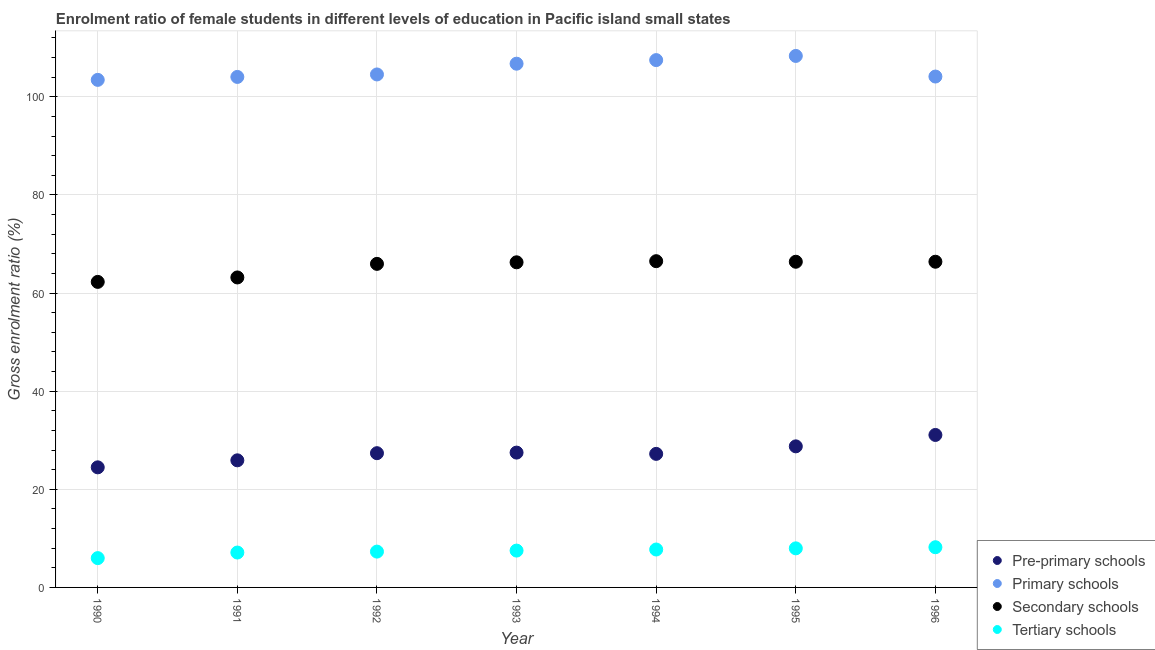Is the number of dotlines equal to the number of legend labels?
Ensure brevity in your answer.  Yes. What is the gross enrolment ratio(male) in tertiary schools in 1994?
Keep it short and to the point. 7.73. Across all years, what is the maximum gross enrolment ratio(male) in primary schools?
Offer a very short reply. 108.34. Across all years, what is the minimum gross enrolment ratio(male) in secondary schools?
Your answer should be compact. 62.28. In which year was the gross enrolment ratio(male) in secondary schools maximum?
Provide a short and direct response. 1994. What is the total gross enrolment ratio(male) in secondary schools in the graph?
Ensure brevity in your answer.  456.99. What is the difference between the gross enrolment ratio(male) in primary schools in 1994 and that in 1996?
Offer a very short reply. 3.35. What is the difference between the gross enrolment ratio(male) in secondary schools in 1994 and the gross enrolment ratio(male) in primary schools in 1995?
Ensure brevity in your answer.  -41.84. What is the average gross enrolment ratio(male) in secondary schools per year?
Your answer should be compact. 65.28. In the year 1995, what is the difference between the gross enrolment ratio(male) in tertiary schools and gross enrolment ratio(male) in pre-primary schools?
Your answer should be very brief. -20.79. In how many years, is the gross enrolment ratio(male) in primary schools greater than 84 %?
Provide a succinct answer. 7. What is the ratio of the gross enrolment ratio(male) in pre-primary schools in 1991 to that in 1995?
Your answer should be compact. 0.9. Is the gross enrolment ratio(male) in pre-primary schools in 1991 less than that in 1993?
Make the answer very short. Yes. What is the difference between the highest and the second highest gross enrolment ratio(male) in primary schools?
Provide a short and direct response. 0.85. What is the difference between the highest and the lowest gross enrolment ratio(male) in secondary schools?
Keep it short and to the point. 4.22. Is the sum of the gross enrolment ratio(male) in primary schools in 1991 and 1994 greater than the maximum gross enrolment ratio(male) in secondary schools across all years?
Give a very brief answer. Yes. Is it the case that in every year, the sum of the gross enrolment ratio(male) in pre-primary schools and gross enrolment ratio(male) in tertiary schools is greater than the sum of gross enrolment ratio(male) in primary schools and gross enrolment ratio(male) in secondary schools?
Keep it short and to the point. No. Is the gross enrolment ratio(male) in pre-primary schools strictly greater than the gross enrolment ratio(male) in secondary schools over the years?
Ensure brevity in your answer.  No. Is the gross enrolment ratio(male) in pre-primary schools strictly less than the gross enrolment ratio(male) in primary schools over the years?
Offer a terse response. Yes. What is the difference between two consecutive major ticks on the Y-axis?
Give a very brief answer. 20. Are the values on the major ticks of Y-axis written in scientific E-notation?
Your response must be concise. No. Does the graph contain any zero values?
Provide a short and direct response. No. Does the graph contain grids?
Your response must be concise. Yes. Where does the legend appear in the graph?
Ensure brevity in your answer.  Bottom right. What is the title of the graph?
Provide a short and direct response. Enrolment ratio of female students in different levels of education in Pacific island small states. Does "International Monetary Fund" appear as one of the legend labels in the graph?
Make the answer very short. No. What is the label or title of the X-axis?
Provide a succinct answer. Year. What is the Gross enrolment ratio (%) of Pre-primary schools in 1990?
Offer a very short reply. 24.48. What is the Gross enrolment ratio (%) in Primary schools in 1990?
Offer a very short reply. 103.46. What is the Gross enrolment ratio (%) of Secondary schools in 1990?
Keep it short and to the point. 62.28. What is the Gross enrolment ratio (%) in Tertiary schools in 1990?
Make the answer very short. 5.97. What is the Gross enrolment ratio (%) in Pre-primary schools in 1991?
Keep it short and to the point. 25.91. What is the Gross enrolment ratio (%) in Primary schools in 1991?
Give a very brief answer. 104.06. What is the Gross enrolment ratio (%) of Secondary schools in 1991?
Offer a terse response. 63.19. What is the Gross enrolment ratio (%) in Tertiary schools in 1991?
Give a very brief answer. 7.11. What is the Gross enrolment ratio (%) of Pre-primary schools in 1992?
Your response must be concise. 27.36. What is the Gross enrolment ratio (%) in Primary schools in 1992?
Provide a succinct answer. 104.57. What is the Gross enrolment ratio (%) of Secondary schools in 1992?
Provide a succinct answer. 65.96. What is the Gross enrolment ratio (%) in Tertiary schools in 1992?
Provide a short and direct response. 7.3. What is the Gross enrolment ratio (%) in Pre-primary schools in 1993?
Provide a short and direct response. 27.48. What is the Gross enrolment ratio (%) in Primary schools in 1993?
Keep it short and to the point. 106.76. What is the Gross enrolment ratio (%) of Secondary schools in 1993?
Ensure brevity in your answer.  66.28. What is the Gross enrolment ratio (%) in Tertiary schools in 1993?
Your answer should be compact. 7.51. What is the Gross enrolment ratio (%) in Pre-primary schools in 1994?
Ensure brevity in your answer.  27.22. What is the Gross enrolment ratio (%) in Primary schools in 1994?
Your answer should be very brief. 107.49. What is the Gross enrolment ratio (%) of Secondary schools in 1994?
Ensure brevity in your answer.  66.51. What is the Gross enrolment ratio (%) of Tertiary schools in 1994?
Provide a succinct answer. 7.73. What is the Gross enrolment ratio (%) in Pre-primary schools in 1995?
Your answer should be very brief. 28.76. What is the Gross enrolment ratio (%) of Primary schools in 1995?
Make the answer very short. 108.34. What is the Gross enrolment ratio (%) of Secondary schools in 1995?
Your answer should be compact. 66.39. What is the Gross enrolment ratio (%) of Tertiary schools in 1995?
Your answer should be very brief. 7.97. What is the Gross enrolment ratio (%) in Pre-primary schools in 1996?
Offer a very short reply. 31.08. What is the Gross enrolment ratio (%) in Primary schools in 1996?
Your answer should be compact. 104.14. What is the Gross enrolment ratio (%) in Secondary schools in 1996?
Your response must be concise. 66.39. What is the Gross enrolment ratio (%) of Tertiary schools in 1996?
Offer a very short reply. 8.19. Across all years, what is the maximum Gross enrolment ratio (%) of Pre-primary schools?
Offer a very short reply. 31.08. Across all years, what is the maximum Gross enrolment ratio (%) of Primary schools?
Ensure brevity in your answer.  108.34. Across all years, what is the maximum Gross enrolment ratio (%) of Secondary schools?
Your answer should be very brief. 66.51. Across all years, what is the maximum Gross enrolment ratio (%) in Tertiary schools?
Keep it short and to the point. 8.19. Across all years, what is the minimum Gross enrolment ratio (%) in Pre-primary schools?
Offer a terse response. 24.48. Across all years, what is the minimum Gross enrolment ratio (%) of Primary schools?
Offer a terse response. 103.46. Across all years, what is the minimum Gross enrolment ratio (%) in Secondary schools?
Your answer should be very brief. 62.28. Across all years, what is the minimum Gross enrolment ratio (%) of Tertiary schools?
Your answer should be very brief. 5.97. What is the total Gross enrolment ratio (%) of Pre-primary schools in the graph?
Ensure brevity in your answer.  192.3. What is the total Gross enrolment ratio (%) in Primary schools in the graph?
Your answer should be compact. 738.84. What is the total Gross enrolment ratio (%) in Secondary schools in the graph?
Your answer should be very brief. 456.99. What is the total Gross enrolment ratio (%) in Tertiary schools in the graph?
Your response must be concise. 51.78. What is the difference between the Gross enrolment ratio (%) in Pre-primary schools in 1990 and that in 1991?
Provide a short and direct response. -1.43. What is the difference between the Gross enrolment ratio (%) of Primary schools in 1990 and that in 1991?
Provide a succinct answer. -0.6. What is the difference between the Gross enrolment ratio (%) of Secondary schools in 1990 and that in 1991?
Ensure brevity in your answer.  -0.9. What is the difference between the Gross enrolment ratio (%) in Tertiary schools in 1990 and that in 1991?
Offer a very short reply. -1.14. What is the difference between the Gross enrolment ratio (%) of Pre-primary schools in 1990 and that in 1992?
Your response must be concise. -2.88. What is the difference between the Gross enrolment ratio (%) of Primary schools in 1990 and that in 1992?
Provide a succinct answer. -1.1. What is the difference between the Gross enrolment ratio (%) of Secondary schools in 1990 and that in 1992?
Your answer should be compact. -3.67. What is the difference between the Gross enrolment ratio (%) of Tertiary schools in 1990 and that in 1992?
Provide a short and direct response. -1.33. What is the difference between the Gross enrolment ratio (%) of Pre-primary schools in 1990 and that in 1993?
Your response must be concise. -3. What is the difference between the Gross enrolment ratio (%) of Primary schools in 1990 and that in 1993?
Make the answer very short. -3.3. What is the difference between the Gross enrolment ratio (%) of Secondary schools in 1990 and that in 1993?
Provide a short and direct response. -3.99. What is the difference between the Gross enrolment ratio (%) in Tertiary schools in 1990 and that in 1993?
Provide a succinct answer. -1.53. What is the difference between the Gross enrolment ratio (%) in Pre-primary schools in 1990 and that in 1994?
Your answer should be very brief. -2.74. What is the difference between the Gross enrolment ratio (%) in Primary schools in 1990 and that in 1994?
Make the answer very short. -4.03. What is the difference between the Gross enrolment ratio (%) in Secondary schools in 1990 and that in 1994?
Keep it short and to the point. -4.22. What is the difference between the Gross enrolment ratio (%) of Tertiary schools in 1990 and that in 1994?
Offer a very short reply. -1.75. What is the difference between the Gross enrolment ratio (%) in Pre-primary schools in 1990 and that in 1995?
Provide a short and direct response. -4.28. What is the difference between the Gross enrolment ratio (%) of Primary schools in 1990 and that in 1995?
Give a very brief answer. -4.88. What is the difference between the Gross enrolment ratio (%) of Secondary schools in 1990 and that in 1995?
Make the answer very short. -4.11. What is the difference between the Gross enrolment ratio (%) of Tertiary schools in 1990 and that in 1995?
Your answer should be very brief. -1.99. What is the difference between the Gross enrolment ratio (%) of Pre-primary schools in 1990 and that in 1996?
Give a very brief answer. -6.6. What is the difference between the Gross enrolment ratio (%) in Primary schools in 1990 and that in 1996?
Your answer should be very brief. -0.68. What is the difference between the Gross enrolment ratio (%) in Secondary schools in 1990 and that in 1996?
Offer a terse response. -4.11. What is the difference between the Gross enrolment ratio (%) of Tertiary schools in 1990 and that in 1996?
Your answer should be compact. -2.22. What is the difference between the Gross enrolment ratio (%) of Pre-primary schools in 1991 and that in 1992?
Offer a very short reply. -1.45. What is the difference between the Gross enrolment ratio (%) in Primary schools in 1991 and that in 1992?
Ensure brevity in your answer.  -0.5. What is the difference between the Gross enrolment ratio (%) in Secondary schools in 1991 and that in 1992?
Ensure brevity in your answer.  -2.77. What is the difference between the Gross enrolment ratio (%) of Tertiary schools in 1991 and that in 1992?
Your response must be concise. -0.19. What is the difference between the Gross enrolment ratio (%) of Pre-primary schools in 1991 and that in 1993?
Provide a succinct answer. -1.57. What is the difference between the Gross enrolment ratio (%) in Primary schools in 1991 and that in 1993?
Give a very brief answer. -2.7. What is the difference between the Gross enrolment ratio (%) of Secondary schools in 1991 and that in 1993?
Offer a terse response. -3.09. What is the difference between the Gross enrolment ratio (%) in Tertiary schools in 1991 and that in 1993?
Your response must be concise. -0.4. What is the difference between the Gross enrolment ratio (%) in Pre-primary schools in 1991 and that in 1994?
Offer a terse response. -1.31. What is the difference between the Gross enrolment ratio (%) in Primary schools in 1991 and that in 1994?
Your answer should be compact. -3.43. What is the difference between the Gross enrolment ratio (%) of Secondary schools in 1991 and that in 1994?
Give a very brief answer. -3.32. What is the difference between the Gross enrolment ratio (%) of Tertiary schools in 1991 and that in 1994?
Offer a terse response. -0.62. What is the difference between the Gross enrolment ratio (%) in Pre-primary schools in 1991 and that in 1995?
Provide a succinct answer. -2.85. What is the difference between the Gross enrolment ratio (%) of Primary schools in 1991 and that in 1995?
Keep it short and to the point. -4.28. What is the difference between the Gross enrolment ratio (%) in Secondary schools in 1991 and that in 1995?
Provide a short and direct response. -3.2. What is the difference between the Gross enrolment ratio (%) of Tertiary schools in 1991 and that in 1995?
Ensure brevity in your answer.  -0.85. What is the difference between the Gross enrolment ratio (%) of Pre-primary schools in 1991 and that in 1996?
Keep it short and to the point. -5.17. What is the difference between the Gross enrolment ratio (%) of Primary schools in 1991 and that in 1996?
Your response must be concise. -0.08. What is the difference between the Gross enrolment ratio (%) in Secondary schools in 1991 and that in 1996?
Give a very brief answer. -3.2. What is the difference between the Gross enrolment ratio (%) of Tertiary schools in 1991 and that in 1996?
Make the answer very short. -1.08. What is the difference between the Gross enrolment ratio (%) in Pre-primary schools in 1992 and that in 1993?
Provide a short and direct response. -0.12. What is the difference between the Gross enrolment ratio (%) of Primary schools in 1992 and that in 1993?
Provide a short and direct response. -2.19. What is the difference between the Gross enrolment ratio (%) of Secondary schools in 1992 and that in 1993?
Your answer should be very brief. -0.32. What is the difference between the Gross enrolment ratio (%) in Tertiary schools in 1992 and that in 1993?
Give a very brief answer. -0.21. What is the difference between the Gross enrolment ratio (%) of Pre-primary schools in 1992 and that in 1994?
Your answer should be very brief. 0.14. What is the difference between the Gross enrolment ratio (%) of Primary schools in 1992 and that in 1994?
Ensure brevity in your answer.  -2.93. What is the difference between the Gross enrolment ratio (%) of Secondary schools in 1992 and that in 1994?
Offer a terse response. -0.55. What is the difference between the Gross enrolment ratio (%) in Tertiary schools in 1992 and that in 1994?
Offer a very short reply. -0.43. What is the difference between the Gross enrolment ratio (%) of Pre-primary schools in 1992 and that in 1995?
Offer a terse response. -1.39. What is the difference between the Gross enrolment ratio (%) of Primary schools in 1992 and that in 1995?
Provide a short and direct response. -3.77. What is the difference between the Gross enrolment ratio (%) in Secondary schools in 1992 and that in 1995?
Provide a short and direct response. -0.43. What is the difference between the Gross enrolment ratio (%) of Tertiary schools in 1992 and that in 1995?
Make the answer very short. -0.66. What is the difference between the Gross enrolment ratio (%) of Pre-primary schools in 1992 and that in 1996?
Offer a very short reply. -3.72. What is the difference between the Gross enrolment ratio (%) in Primary schools in 1992 and that in 1996?
Your answer should be compact. 0.43. What is the difference between the Gross enrolment ratio (%) in Secondary schools in 1992 and that in 1996?
Your response must be concise. -0.44. What is the difference between the Gross enrolment ratio (%) in Tertiary schools in 1992 and that in 1996?
Your answer should be compact. -0.89. What is the difference between the Gross enrolment ratio (%) of Pre-primary schools in 1993 and that in 1994?
Ensure brevity in your answer.  0.26. What is the difference between the Gross enrolment ratio (%) in Primary schools in 1993 and that in 1994?
Give a very brief answer. -0.73. What is the difference between the Gross enrolment ratio (%) of Secondary schools in 1993 and that in 1994?
Your response must be concise. -0.23. What is the difference between the Gross enrolment ratio (%) in Tertiary schools in 1993 and that in 1994?
Make the answer very short. -0.22. What is the difference between the Gross enrolment ratio (%) in Pre-primary schools in 1993 and that in 1995?
Your answer should be compact. -1.27. What is the difference between the Gross enrolment ratio (%) of Primary schools in 1993 and that in 1995?
Your answer should be very brief. -1.58. What is the difference between the Gross enrolment ratio (%) in Secondary schools in 1993 and that in 1995?
Your response must be concise. -0.11. What is the difference between the Gross enrolment ratio (%) of Tertiary schools in 1993 and that in 1995?
Offer a very short reply. -0.46. What is the difference between the Gross enrolment ratio (%) in Pre-primary schools in 1993 and that in 1996?
Your answer should be compact. -3.6. What is the difference between the Gross enrolment ratio (%) in Primary schools in 1993 and that in 1996?
Offer a very short reply. 2.62. What is the difference between the Gross enrolment ratio (%) in Secondary schools in 1993 and that in 1996?
Your response must be concise. -0.12. What is the difference between the Gross enrolment ratio (%) of Tertiary schools in 1993 and that in 1996?
Provide a succinct answer. -0.69. What is the difference between the Gross enrolment ratio (%) in Pre-primary schools in 1994 and that in 1995?
Your answer should be compact. -1.53. What is the difference between the Gross enrolment ratio (%) of Primary schools in 1994 and that in 1995?
Give a very brief answer. -0.85. What is the difference between the Gross enrolment ratio (%) in Secondary schools in 1994 and that in 1995?
Provide a short and direct response. 0.12. What is the difference between the Gross enrolment ratio (%) of Tertiary schools in 1994 and that in 1995?
Give a very brief answer. -0.24. What is the difference between the Gross enrolment ratio (%) in Pre-primary schools in 1994 and that in 1996?
Ensure brevity in your answer.  -3.86. What is the difference between the Gross enrolment ratio (%) of Primary schools in 1994 and that in 1996?
Provide a succinct answer. 3.35. What is the difference between the Gross enrolment ratio (%) of Secondary schools in 1994 and that in 1996?
Ensure brevity in your answer.  0.11. What is the difference between the Gross enrolment ratio (%) of Tertiary schools in 1994 and that in 1996?
Keep it short and to the point. -0.46. What is the difference between the Gross enrolment ratio (%) in Pre-primary schools in 1995 and that in 1996?
Offer a very short reply. -2.32. What is the difference between the Gross enrolment ratio (%) in Primary schools in 1995 and that in 1996?
Keep it short and to the point. 4.2. What is the difference between the Gross enrolment ratio (%) of Secondary schools in 1995 and that in 1996?
Provide a short and direct response. -0. What is the difference between the Gross enrolment ratio (%) of Tertiary schools in 1995 and that in 1996?
Offer a very short reply. -0.23. What is the difference between the Gross enrolment ratio (%) in Pre-primary schools in 1990 and the Gross enrolment ratio (%) in Primary schools in 1991?
Offer a very short reply. -79.58. What is the difference between the Gross enrolment ratio (%) of Pre-primary schools in 1990 and the Gross enrolment ratio (%) of Secondary schools in 1991?
Offer a very short reply. -38.71. What is the difference between the Gross enrolment ratio (%) in Pre-primary schools in 1990 and the Gross enrolment ratio (%) in Tertiary schools in 1991?
Provide a short and direct response. 17.37. What is the difference between the Gross enrolment ratio (%) in Primary schools in 1990 and the Gross enrolment ratio (%) in Secondary schools in 1991?
Give a very brief answer. 40.28. What is the difference between the Gross enrolment ratio (%) in Primary schools in 1990 and the Gross enrolment ratio (%) in Tertiary schools in 1991?
Keep it short and to the point. 96.35. What is the difference between the Gross enrolment ratio (%) of Secondary schools in 1990 and the Gross enrolment ratio (%) of Tertiary schools in 1991?
Your response must be concise. 55.17. What is the difference between the Gross enrolment ratio (%) in Pre-primary schools in 1990 and the Gross enrolment ratio (%) in Primary schools in 1992?
Keep it short and to the point. -80.09. What is the difference between the Gross enrolment ratio (%) of Pre-primary schools in 1990 and the Gross enrolment ratio (%) of Secondary schools in 1992?
Your response must be concise. -41.48. What is the difference between the Gross enrolment ratio (%) of Pre-primary schools in 1990 and the Gross enrolment ratio (%) of Tertiary schools in 1992?
Your response must be concise. 17.18. What is the difference between the Gross enrolment ratio (%) of Primary schools in 1990 and the Gross enrolment ratio (%) of Secondary schools in 1992?
Your response must be concise. 37.51. What is the difference between the Gross enrolment ratio (%) in Primary schools in 1990 and the Gross enrolment ratio (%) in Tertiary schools in 1992?
Offer a very short reply. 96.16. What is the difference between the Gross enrolment ratio (%) of Secondary schools in 1990 and the Gross enrolment ratio (%) of Tertiary schools in 1992?
Your response must be concise. 54.98. What is the difference between the Gross enrolment ratio (%) in Pre-primary schools in 1990 and the Gross enrolment ratio (%) in Primary schools in 1993?
Provide a short and direct response. -82.28. What is the difference between the Gross enrolment ratio (%) in Pre-primary schools in 1990 and the Gross enrolment ratio (%) in Secondary schools in 1993?
Keep it short and to the point. -41.8. What is the difference between the Gross enrolment ratio (%) of Pre-primary schools in 1990 and the Gross enrolment ratio (%) of Tertiary schools in 1993?
Provide a short and direct response. 16.97. What is the difference between the Gross enrolment ratio (%) in Primary schools in 1990 and the Gross enrolment ratio (%) in Secondary schools in 1993?
Your response must be concise. 37.19. What is the difference between the Gross enrolment ratio (%) of Primary schools in 1990 and the Gross enrolment ratio (%) of Tertiary schools in 1993?
Make the answer very short. 95.96. What is the difference between the Gross enrolment ratio (%) of Secondary schools in 1990 and the Gross enrolment ratio (%) of Tertiary schools in 1993?
Provide a succinct answer. 54.77. What is the difference between the Gross enrolment ratio (%) of Pre-primary schools in 1990 and the Gross enrolment ratio (%) of Primary schools in 1994?
Provide a short and direct response. -83.01. What is the difference between the Gross enrolment ratio (%) of Pre-primary schools in 1990 and the Gross enrolment ratio (%) of Secondary schools in 1994?
Provide a succinct answer. -42.02. What is the difference between the Gross enrolment ratio (%) of Pre-primary schools in 1990 and the Gross enrolment ratio (%) of Tertiary schools in 1994?
Your answer should be very brief. 16.75. What is the difference between the Gross enrolment ratio (%) of Primary schools in 1990 and the Gross enrolment ratio (%) of Secondary schools in 1994?
Offer a very short reply. 36.96. What is the difference between the Gross enrolment ratio (%) in Primary schools in 1990 and the Gross enrolment ratio (%) in Tertiary schools in 1994?
Offer a terse response. 95.74. What is the difference between the Gross enrolment ratio (%) in Secondary schools in 1990 and the Gross enrolment ratio (%) in Tertiary schools in 1994?
Your answer should be compact. 54.55. What is the difference between the Gross enrolment ratio (%) of Pre-primary schools in 1990 and the Gross enrolment ratio (%) of Primary schools in 1995?
Make the answer very short. -83.86. What is the difference between the Gross enrolment ratio (%) of Pre-primary schools in 1990 and the Gross enrolment ratio (%) of Secondary schools in 1995?
Keep it short and to the point. -41.91. What is the difference between the Gross enrolment ratio (%) of Pre-primary schools in 1990 and the Gross enrolment ratio (%) of Tertiary schools in 1995?
Ensure brevity in your answer.  16.52. What is the difference between the Gross enrolment ratio (%) in Primary schools in 1990 and the Gross enrolment ratio (%) in Secondary schools in 1995?
Your response must be concise. 37.08. What is the difference between the Gross enrolment ratio (%) of Primary schools in 1990 and the Gross enrolment ratio (%) of Tertiary schools in 1995?
Make the answer very short. 95.5. What is the difference between the Gross enrolment ratio (%) in Secondary schools in 1990 and the Gross enrolment ratio (%) in Tertiary schools in 1995?
Give a very brief answer. 54.32. What is the difference between the Gross enrolment ratio (%) of Pre-primary schools in 1990 and the Gross enrolment ratio (%) of Primary schools in 1996?
Offer a terse response. -79.66. What is the difference between the Gross enrolment ratio (%) in Pre-primary schools in 1990 and the Gross enrolment ratio (%) in Secondary schools in 1996?
Keep it short and to the point. -41.91. What is the difference between the Gross enrolment ratio (%) of Pre-primary schools in 1990 and the Gross enrolment ratio (%) of Tertiary schools in 1996?
Provide a short and direct response. 16.29. What is the difference between the Gross enrolment ratio (%) in Primary schools in 1990 and the Gross enrolment ratio (%) in Secondary schools in 1996?
Give a very brief answer. 37.07. What is the difference between the Gross enrolment ratio (%) of Primary schools in 1990 and the Gross enrolment ratio (%) of Tertiary schools in 1996?
Provide a short and direct response. 95.27. What is the difference between the Gross enrolment ratio (%) in Secondary schools in 1990 and the Gross enrolment ratio (%) in Tertiary schools in 1996?
Your answer should be very brief. 54.09. What is the difference between the Gross enrolment ratio (%) in Pre-primary schools in 1991 and the Gross enrolment ratio (%) in Primary schools in 1992?
Keep it short and to the point. -78.66. What is the difference between the Gross enrolment ratio (%) of Pre-primary schools in 1991 and the Gross enrolment ratio (%) of Secondary schools in 1992?
Your response must be concise. -40.05. What is the difference between the Gross enrolment ratio (%) of Pre-primary schools in 1991 and the Gross enrolment ratio (%) of Tertiary schools in 1992?
Make the answer very short. 18.61. What is the difference between the Gross enrolment ratio (%) of Primary schools in 1991 and the Gross enrolment ratio (%) of Secondary schools in 1992?
Keep it short and to the point. 38.11. What is the difference between the Gross enrolment ratio (%) in Primary schools in 1991 and the Gross enrolment ratio (%) in Tertiary schools in 1992?
Provide a short and direct response. 96.76. What is the difference between the Gross enrolment ratio (%) in Secondary schools in 1991 and the Gross enrolment ratio (%) in Tertiary schools in 1992?
Offer a terse response. 55.89. What is the difference between the Gross enrolment ratio (%) in Pre-primary schools in 1991 and the Gross enrolment ratio (%) in Primary schools in 1993?
Offer a very short reply. -80.85. What is the difference between the Gross enrolment ratio (%) in Pre-primary schools in 1991 and the Gross enrolment ratio (%) in Secondary schools in 1993?
Provide a short and direct response. -40.37. What is the difference between the Gross enrolment ratio (%) of Pre-primary schools in 1991 and the Gross enrolment ratio (%) of Tertiary schools in 1993?
Your response must be concise. 18.4. What is the difference between the Gross enrolment ratio (%) of Primary schools in 1991 and the Gross enrolment ratio (%) of Secondary schools in 1993?
Your answer should be very brief. 37.79. What is the difference between the Gross enrolment ratio (%) of Primary schools in 1991 and the Gross enrolment ratio (%) of Tertiary schools in 1993?
Your answer should be very brief. 96.56. What is the difference between the Gross enrolment ratio (%) of Secondary schools in 1991 and the Gross enrolment ratio (%) of Tertiary schools in 1993?
Your response must be concise. 55.68. What is the difference between the Gross enrolment ratio (%) in Pre-primary schools in 1991 and the Gross enrolment ratio (%) in Primary schools in 1994?
Ensure brevity in your answer.  -81.58. What is the difference between the Gross enrolment ratio (%) of Pre-primary schools in 1991 and the Gross enrolment ratio (%) of Secondary schools in 1994?
Your answer should be very brief. -40.59. What is the difference between the Gross enrolment ratio (%) of Pre-primary schools in 1991 and the Gross enrolment ratio (%) of Tertiary schools in 1994?
Offer a very short reply. 18.18. What is the difference between the Gross enrolment ratio (%) of Primary schools in 1991 and the Gross enrolment ratio (%) of Secondary schools in 1994?
Your answer should be very brief. 37.56. What is the difference between the Gross enrolment ratio (%) in Primary schools in 1991 and the Gross enrolment ratio (%) in Tertiary schools in 1994?
Make the answer very short. 96.34. What is the difference between the Gross enrolment ratio (%) in Secondary schools in 1991 and the Gross enrolment ratio (%) in Tertiary schools in 1994?
Your answer should be compact. 55.46. What is the difference between the Gross enrolment ratio (%) in Pre-primary schools in 1991 and the Gross enrolment ratio (%) in Primary schools in 1995?
Provide a short and direct response. -82.43. What is the difference between the Gross enrolment ratio (%) in Pre-primary schools in 1991 and the Gross enrolment ratio (%) in Secondary schools in 1995?
Keep it short and to the point. -40.48. What is the difference between the Gross enrolment ratio (%) in Pre-primary schools in 1991 and the Gross enrolment ratio (%) in Tertiary schools in 1995?
Offer a very short reply. 17.95. What is the difference between the Gross enrolment ratio (%) in Primary schools in 1991 and the Gross enrolment ratio (%) in Secondary schools in 1995?
Give a very brief answer. 37.68. What is the difference between the Gross enrolment ratio (%) in Primary schools in 1991 and the Gross enrolment ratio (%) in Tertiary schools in 1995?
Keep it short and to the point. 96.1. What is the difference between the Gross enrolment ratio (%) in Secondary schools in 1991 and the Gross enrolment ratio (%) in Tertiary schools in 1995?
Make the answer very short. 55.22. What is the difference between the Gross enrolment ratio (%) of Pre-primary schools in 1991 and the Gross enrolment ratio (%) of Primary schools in 1996?
Ensure brevity in your answer.  -78.23. What is the difference between the Gross enrolment ratio (%) of Pre-primary schools in 1991 and the Gross enrolment ratio (%) of Secondary schools in 1996?
Keep it short and to the point. -40.48. What is the difference between the Gross enrolment ratio (%) in Pre-primary schools in 1991 and the Gross enrolment ratio (%) in Tertiary schools in 1996?
Your response must be concise. 17.72. What is the difference between the Gross enrolment ratio (%) in Primary schools in 1991 and the Gross enrolment ratio (%) in Secondary schools in 1996?
Offer a very short reply. 37.67. What is the difference between the Gross enrolment ratio (%) in Primary schools in 1991 and the Gross enrolment ratio (%) in Tertiary schools in 1996?
Make the answer very short. 95.87. What is the difference between the Gross enrolment ratio (%) in Secondary schools in 1991 and the Gross enrolment ratio (%) in Tertiary schools in 1996?
Give a very brief answer. 54.99. What is the difference between the Gross enrolment ratio (%) in Pre-primary schools in 1992 and the Gross enrolment ratio (%) in Primary schools in 1993?
Make the answer very short. -79.4. What is the difference between the Gross enrolment ratio (%) of Pre-primary schools in 1992 and the Gross enrolment ratio (%) of Secondary schools in 1993?
Offer a very short reply. -38.91. What is the difference between the Gross enrolment ratio (%) in Pre-primary schools in 1992 and the Gross enrolment ratio (%) in Tertiary schools in 1993?
Make the answer very short. 19.86. What is the difference between the Gross enrolment ratio (%) of Primary schools in 1992 and the Gross enrolment ratio (%) of Secondary schools in 1993?
Offer a very short reply. 38.29. What is the difference between the Gross enrolment ratio (%) of Primary schools in 1992 and the Gross enrolment ratio (%) of Tertiary schools in 1993?
Your response must be concise. 97.06. What is the difference between the Gross enrolment ratio (%) of Secondary schools in 1992 and the Gross enrolment ratio (%) of Tertiary schools in 1993?
Make the answer very short. 58.45. What is the difference between the Gross enrolment ratio (%) of Pre-primary schools in 1992 and the Gross enrolment ratio (%) of Primary schools in 1994?
Your answer should be very brief. -80.13. What is the difference between the Gross enrolment ratio (%) in Pre-primary schools in 1992 and the Gross enrolment ratio (%) in Secondary schools in 1994?
Give a very brief answer. -39.14. What is the difference between the Gross enrolment ratio (%) of Pre-primary schools in 1992 and the Gross enrolment ratio (%) of Tertiary schools in 1994?
Provide a succinct answer. 19.64. What is the difference between the Gross enrolment ratio (%) of Primary schools in 1992 and the Gross enrolment ratio (%) of Secondary schools in 1994?
Give a very brief answer. 38.06. What is the difference between the Gross enrolment ratio (%) of Primary schools in 1992 and the Gross enrolment ratio (%) of Tertiary schools in 1994?
Offer a very short reply. 96.84. What is the difference between the Gross enrolment ratio (%) of Secondary schools in 1992 and the Gross enrolment ratio (%) of Tertiary schools in 1994?
Your answer should be compact. 58.23. What is the difference between the Gross enrolment ratio (%) of Pre-primary schools in 1992 and the Gross enrolment ratio (%) of Primary schools in 1995?
Give a very brief answer. -80.98. What is the difference between the Gross enrolment ratio (%) of Pre-primary schools in 1992 and the Gross enrolment ratio (%) of Secondary schools in 1995?
Give a very brief answer. -39.02. What is the difference between the Gross enrolment ratio (%) of Pre-primary schools in 1992 and the Gross enrolment ratio (%) of Tertiary schools in 1995?
Keep it short and to the point. 19.4. What is the difference between the Gross enrolment ratio (%) of Primary schools in 1992 and the Gross enrolment ratio (%) of Secondary schools in 1995?
Keep it short and to the point. 38.18. What is the difference between the Gross enrolment ratio (%) of Primary schools in 1992 and the Gross enrolment ratio (%) of Tertiary schools in 1995?
Make the answer very short. 96.6. What is the difference between the Gross enrolment ratio (%) in Secondary schools in 1992 and the Gross enrolment ratio (%) in Tertiary schools in 1995?
Provide a succinct answer. 57.99. What is the difference between the Gross enrolment ratio (%) of Pre-primary schools in 1992 and the Gross enrolment ratio (%) of Primary schools in 1996?
Give a very brief answer. -76.78. What is the difference between the Gross enrolment ratio (%) in Pre-primary schools in 1992 and the Gross enrolment ratio (%) in Secondary schools in 1996?
Offer a very short reply. -39.03. What is the difference between the Gross enrolment ratio (%) in Pre-primary schools in 1992 and the Gross enrolment ratio (%) in Tertiary schools in 1996?
Your response must be concise. 19.17. What is the difference between the Gross enrolment ratio (%) in Primary schools in 1992 and the Gross enrolment ratio (%) in Secondary schools in 1996?
Provide a succinct answer. 38.18. What is the difference between the Gross enrolment ratio (%) of Primary schools in 1992 and the Gross enrolment ratio (%) of Tertiary schools in 1996?
Your response must be concise. 96.38. What is the difference between the Gross enrolment ratio (%) in Secondary schools in 1992 and the Gross enrolment ratio (%) in Tertiary schools in 1996?
Give a very brief answer. 57.76. What is the difference between the Gross enrolment ratio (%) in Pre-primary schools in 1993 and the Gross enrolment ratio (%) in Primary schools in 1994?
Offer a very short reply. -80.01. What is the difference between the Gross enrolment ratio (%) in Pre-primary schools in 1993 and the Gross enrolment ratio (%) in Secondary schools in 1994?
Offer a terse response. -39.02. What is the difference between the Gross enrolment ratio (%) in Pre-primary schools in 1993 and the Gross enrolment ratio (%) in Tertiary schools in 1994?
Provide a succinct answer. 19.76. What is the difference between the Gross enrolment ratio (%) in Primary schools in 1993 and the Gross enrolment ratio (%) in Secondary schools in 1994?
Offer a terse response. 40.26. What is the difference between the Gross enrolment ratio (%) of Primary schools in 1993 and the Gross enrolment ratio (%) of Tertiary schools in 1994?
Provide a succinct answer. 99.03. What is the difference between the Gross enrolment ratio (%) in Secondary schools in 1993 and the Gross enrolment ratio (%) in Tertiary schools in 1994?
Your answer should be very brief. 58.55. What is the difference between the Gross enrolment ratio (%) of Pre-primary schools in 1993 and the Gross enrolment ratio (%) of Primary schools in 1995?
Give a very brief answer. -80.86. What is the difference between the Gross enrolment ratio (%) of Pre-primary schools in 1993 and the Gross enrolment ratio (%) of Secondary schools in 1995?
Your response must be concise. -38.9. What is the difference between the Gross enrolment ratio (%) of Pre-primary schools in 1993 and the Gross enrolment ratio (%) of Tertiary schools in 1995?
Provide a short and direct response. 19.52. What is the difference between the Gross enrolment ratio (%) in Primary schools in 1993 and the Gross enrolment ratio (%) in Secondary schools in 1995?
Provide a short and direct response. 40.37. What is the difference between the Gross enrolment ratio (%) of Primary schools in 1993 and the Gross enrolment ratio (%) of Tertiary schools in 1995?
Ensure brevity in your answer.  98.8. What is the difference between the Gross enrolment ratio (%) of Secondary schools in 1993 and the Gross enrolment ratio (%) of Tertiary schools in 1995?
Your answer should be very brief. 58.31. What is the difference between the Gross enrolment ratio (%) in Pre-primary schools in 1993 and the Gross enrolment ratio (%) in Primary schools in 1996?
Your answer should be compact. -76.66. What is the difference between the Gross enrolment ratio (%) in Pre-primary schools in 1993 and the Gross enrolment ratio (%) in Secondary schools in 1996?
Offer a very short reply. -38.91. What is the difference between the Gross enrolment ratio (%) in Pre-primary schools in 1993 and the Gross enrolment ratio (%) in Tertiary schools in 1996?
Provide a short and direct response. 19.29. What is the difference between the Gross enrolment ratio (%) in Primary schools in 1993 and the Gross enrolment ratio (%) in Secondary schools in 1996?
Offer a very short reply. 40.37. What is the difference between the Gross enrolment ratio (%) in Primary schools in 1993 and the Gross enrolment ratio (%) in Tertiary schools in 1996?
Offer a very short reply. 98.57. What is the difference between the Gross enrolment ratio (%) in Secondary schools in 1993 and the Gross enrolment ratio (%) in Tertiary schools in 1996?
Your answer should be very brief. 58.08. What is the difference between the Gross enrolment ratio (%) of Pre-primary schools in 1994 and the Gross enrolment ratio (%) of Primary schools in 1995?
Give a very brief answer. -81.12. What is the difference between the Gross enrolment ratio (%) of Pre-primary schools in 1994 and the Gross enrolment ratio (%) of Secondary schools in 1995?
Offer a very short reply. -39.16. What is the difference between the Gross enrolment ratio (%) in Pre-primary schools in 1994 and the Gross enrolment ratio (%) in Tertiary schools in 1995?
Provide a succinct answer. 19.26. What is the difference between the Gross enrolment ratio (%) in Primary schools in 1994 and the Gross enrolment ratio (%) in Secondary schools in 1995?
Make the answer very short. 41.11. What is the difference between the Gross enrolment ratio (%) of Primary schools in 1994 and the Gross enrolment ratio (%) of Tertiary schools in 1995?
Offer a terse response. 99.53. What is the difference between the Gross enrolment ratio (%) in Secondary schools in 1994 and the Gross enrolment ratio (%) in Tertiary schools in 1995?
Offer a terse response. 58.54. What is the difference between the Gross enrolment ratio (%) in Pre-primary schools in 1994 and the Gross enrolment ratio (%) in Primary schools in 1996?
Ensure brevity in your answer.  -76.92. What is the difference between the Gross enrolment ratio (%) of Pre-primary schools in 1994 and the Gross enrolment ratio (%) of Secondary schools in 1996?
Ensure brevity in your answer.  -39.17. What is the difference between the Gross enrolment ratio (%) of Pre-primary schools in 1994 and the Gross enrolment ratio (%) of Tertiary schools in 1996?
Keep it short and to the point. 19.03. What is the difference between the Gross enrolment ratio (%) in Primary schools in 1994 and the Gross enrolment ratio (%) in Secondary schools in 1996?
Your response must be concise. 41.1. What is the difference between the Gross enrolment ratio (%) in Primary schools in 1994 and the Gross enrolment ratio (%) in Tertiary schools in 1996?
Offer a terse response. 99.3. What is the difference between the Gross enrolment ratio (%) of Secondary schools in 1994 and the Gross enrolment ratio (%) of Tertiary schools in 1996?
Keep it short and to the point. 58.31. What is the difference between the Gross enrolment ratio (%) in Pre-primary schools in 1995 and the Gross enrolment ratio (%) in Primary schools in 1996?
Keep it short and to the point. -75.39. What is the difference between the Gross enrolment ratio (%) in Pre-primary schools in 1995 and the Gross enrolment ratio (%) in Secondary schools in 1996?
Keep it short and to the point. -37.63. What is the difference between the Gross enrolment ratio (%) of Pre-primary schools in 1995 and the Gross enrolment ratio (%) of Tertiary schools in 1996?
Ensure brevity in your answer.  20.56. What is the difference between the Gross enrolment ratio (%) of Primary schools in 1995 and the Gross enrolment ratio (%) of Secondary schools in 1996?
Offer a terse response. 41.95. What is the difference between the Gross enrolment ratio (%) of Primary schools in 1995 and the Gross enrolment ratio (%) of Tertiary schools in 1996?
Your response must be concise. 100.15. What is the difference between the Gross enrolment ratio (%) of Secondary schools in 1995 and the Gross enrolment ratio (%) of Tertiary schools in 1996?
Provide a succinct answer. 58.19. What is the average Gross enrolment ratio (%) in Pre-primary schools per year?
Provide a short and direct response. 27.47. What is the average Gross enrolment ratio (%) in Primary schools per year?
Offer a terse response. 105.55. What is the average Gross enrolment ratio (%) of Secondary schools per year?
Provide a short and direct response. 65.28. What is the average Gross enrolment ratio (%) in Tertiary schools per year?
Offer a very short reply. 7.4. In the year 1990, what is the difference between the Gross enrolment ratio (%) of Pre-primary schools and Gross enrolment ratio (%) of Primary schools?
Your answer should be compact. -78.98. In the year 1990, what is the difference between the Gross enrolment ratio (%) of Pre-primary schools and Gross enrolment ratio (%) of Secondary schools?
Provide a short and direct response. -37.8. In the year 1990, what is the difference between the Gross enrolment ratio (%) of Pre-primary schools and Gross enrolment ratio (%) of Tertiary schools?
Your response must be concise. 18.51. In the year 1990, what is the difference between the Gross enrolment ratio (%) of Primary schools and Gross enrolment ratio (%) of Secondary schools?
Keep it short and to the point. 41.18. In the year 1990, what is the difference between the Gross enrolment ratio (%) in Primary schools and Gross enrolment ratio (%) in Tertiary schools?
Keep it short and to the point. 97.49. In the year 1990, what is the difference between the Gross enrolment ratio (%) of Secondary schools and Gross enrolment ratio (%) of Tertiary schools?
Ensure brevity in your answer.  56.31. In the year 1991, what is the difference between the Gross enrolment ratio (%) in Pre-primary schools and Gross enrolment ratio (%) in Primary schools?
Ensure brevity in your answer.  -78.15. In the year 1991, what is the difference between the Gross enrolment ratio (%) of Pre-primary schools and Gross enrolment ratio (%) of Secondary schools?
Give a very brief answer. -37.28. In the year 1991, what is the difference between the Gross enrolment ratio (%) in Pre-primary schools and Gross enrolment ratio (%) in Tertiary schools?
Your answer should be compact. 18.8. In the year 1991, what is the difference between the Gross enrolment ratio (%) in Primary schools and Gross enrolment ratio (%) in Secondary schools?
Offer a very short reply. 40.88. In the year 1991, what is the difference between the Gross enrolment ratio (%) of Primary schools and Gross enrolment ratio (%) of Tertiary schools?
Ensure brevity in your answer.  96.95. In the year 1991, what is the difference between the Gross enrolment ratio (%) in Secondary schools and Gross enrolment ratio (%) in Tertiary schools?
Your answer should be very brief. 56.08. In the year 1992, what is the difference between the Gross enrolment ratio (%) in Pre-primary schools and Gross enrolment ratio (%) in Primary schools?
Ensure brevity in your answer.  -77.2. In the year 1992, what is the difference between the Gross enrolment ratio (%) of Pre-primary schools and Gross enrolment ratio (%) of Secondary schools?
Make the answer very short. -38.59. In the year 1992, what is the difference between the Gross enrolment ratio (%) in Pre-primary schools and Gross enrolment ratio (%) in Tertiary schools?
Keep it short and to the point. 20.06. In the year 1992, what is the difference between the Gross enrolment ratio (%) in Primary schools and Gross enrolment ratio (%) in Secondary schools?
Ensure brevity in your answer.  38.61. In the year 1992, what is the difference between the Gross enrolment ratio (%) of Primary schools and Gross enrolment ratio (%) of Tertiary schools?
Give a very brief answer. 97.27. In the year 1992, what is the difference between the Gross enrolment ratio (%) of Secondary schools and Gross enrolment ratio (%) of Tertiary schools?
Ensure brevity in your answer.  58.66. In the year 1993, what is the difference between the Gross enrolment ratio (%) of Pre-primary schools and Gross enrolment ratio (%) of Primary schools?
Give a very brief answer. -79.28. In the year 1993, what is the difference between the Gross enrolment ratio (%) of Pre-primary schools and Gross enrolment ratio (%) of Secondary schools?
Keep it short and to the point. -38.79. In the year 1993, what is the difference between the Gross enrolment ratio (%) of Pre-primary schools and Gross enrolment ratio (%) of Tertiary schools?
Ensure brevity in your answer.  19.98. In the year 1993, what is the difference between the Gross enrolment ratio (%) of Primary schools and Gross enrolment ratio (%) of Secondary schools?
Keep it short and to the point. 40.48. In the year 1993, what is the difference between the Gross enrolment ratio (%) in Primary schools and Gross enrolment ratio (%) in Tertiary schools?
Your response must be concise. 99.25. In the year 1993, what is the difference between the Gross enrolment ratio (%) in Secondary schools and Gross enrolment ratio (%) in Tertiary schools?
Provide a succinct answer. 58.77. In the year 1994, what is the difference between the Gross enrolment ratio (%) of Pre-primary schools and Gross enrolment ratio (%) of Primary schools?
Offer a very short reply. -80.27. In the year 1994, what is the difference between the Gross enrolment ratio (%) in Pre-primary schools and Gross enrolment ratio (%) in Secondary schools?
Provide a succinct answer. -39.28. In the year 1994, what is the difference between the Gross enrolment ratio (%) in Pre-primary schools and Gross enrolment ratio (%) in Tertiary schools?
Provide a succinct answer. 19.5. In the year 1994, what is the difference between the Gross enrolment ratio (%) of Primary schools and Gross enrolment ratio (%) of Secondary schools?
Your answer should be very brief. 40.99. In the year 1994, what is the difference between the Gross enrolment ratio (%) of Primary schools and Gross enrolment ratio (%) of Tertiary schools?
Your answer should be compact. 99.77. In the year 1994, what is the difference between the Gross enrolment ratio (%) of Secondary schools and Gross enrolment ratio (%) of Tertiary schools?
Your answer should be very brief. 58.78. In the year 1995, what is the difference between the Gross enrolment ratio (%) of Pre-primary schools and Gross enrolment ratio (%) of Primary schools?
Your answer should be very brief. -79.59. In the year 1995, what is the difference between the Gross enrolment ratio (%) of Pre-primary schools and Gross enrolment ratio (%) of Secondary schools?
Ensure brevity in your answer.  -37.63. In the year 1995, what is the difference between the Gross enrolment ratio (%) in Pre-primary schools and Gross enrolment ratio (%) in Tertiary schools?
Your response must be concise. 20.79. In the year 1995, what is the difference between the Gross enrolment ratio (%) in Primary schools and Gross enrolment ratio (%) in Secondary schools?
Your response must be concise. 41.96. In the year 1995, what is the difference between the Gross enrolment ratio (%) of Primary schools and Gross enrolment ratio (%) of Tertiary schools?
Give a very brief answer. 100.38. In the year 1995, what is the difference between the Gross enrolment ratio (%) of Secondary schools and Gross enrolment ratio (%) of Tertiary schools?
Give a very brief answer. 58.42. In the year 1996, what is the difference between the Gross enrolment ratio (%) in Pre-primary schools and Gross enrolment ratio (%) in Primary schools?
Provide a succinct answer. -73.06. In the year 1996, what is the difference between the Gross enrolment ratio (%) of Pre-primary schools and Gross enrolment ratio (%) of Secondary schools?
Provide a succinct answer. -35.31. In the year 1996, what is the difference between the Gross enrolment ratio (%) in Pre-primary schools and Gross enrolment ratio (%) in Tertiary schools?
Provide a succinct answer. 22.89. In the year 1996, what is the difference between the Gross enrolment ratio (%) in Primary schools and Gross enrolment ratio (%) in Secondary schools?
Provide a succinct answer. 37.75. In the year 1996, what is the difference between the Gross enrolment ratio (%) of Primary schools and Gross enrolment ratio (%) of Tertiary schools?
Ensure brevity in your answer.  95.95. In the year 1996, what is the difference between the Gross enrolment ratio (%) in Secondary schools and Gross enrolment ratio (%) in Tertiary schools?
Offer a terse response. 58.2. What is the ratio of the Gross enrolment ratio (%) of Pre-primary schools in 1990 to that in 1991?
Ensure brevity in your answer.  0.94. What is the ratio of the Gross enrolment ratio (%) of Secondary schools in 1990 to that in 1991?
Give a very brief answer. 0.99. What is the ratio of the Gross enrolment ratio (%) of Tertiary schools in 1990 to that in 1991?
Ensure brevity in your answer.  0.84. What is the ratio of the Gross enrolment ratio (%) of Pre-primary schools in 1990 to that in 1992?
Your answer should be very brief. 0.89. What is the ratio of the Gross enrolment ratio (%) in Secondary schools in 1990 to that in 1992?
Offer a terse response. 0.94. What is the ratio of the Gross enrolment ratio (%) of Tertiary schools in 1990 to that in 1992?
Ensure brevity in your answer.  0.82. What is the ratio of the Gross enrolment ratio (%) in Pre-primary schools in 1990 to that in 1993?
Your response must be concise. 0.89. What is the ratio of the Gross enrolment ratio (%) in Primary schools in 1990 to that in 1993?
Ensure brevity in your answer.  0.97. What is the ratio of the Gross enrolment ratio (%) of Secondary schools in 1990 to that in 1993?
Your answer should be compact. 0.94. What is the ratio of the Gross enrolment ratio (%) of Tertiary schools in 1990 to that in 1993?
Offer a very short reply. 0.8. What is the ratio of the Gross enrolment ratio (%) of Pre-primary schools in 1990 to that in 1994?
Your answer should be very brief. 0.9. What is the ratio of the Gross enrolment ratio (%) of Primary schools in 1990 to that in 1994?
Your response must be concise. 0.96. What is the ratio of the Gross enrolment ratio (%) in Secondary schools in 1990 to that in 1994?
Your answer should be very brief. 0.94. What is the ratio of the Gross enrolment ratio (%) in Tertiary schools in 1990 to that in 1994?
Provide a short and direct response. 0.77. What is the ratio of the Gross enrolment ratio (%) in Pre-primary schools in 1990 to that in 1995?
Provide a short and direct response. 0.85. What is the ratio of the Gross enrolment ratio (%) of Primary schools in 1990 to that in 1995?
Ensure brevity in your answer.  0.95. What is the ratio of the Gross enrolment ratio (%) in Secondary schools in 1990 to that in 1995?
Your response must be concise. 0.94. What is the ratio of the Gross enrolment ratio (%) of Tertiary schools in 1990 to that in 1995?
Provide a succinct answer. 0.75. What is the ratio of the Gross enrolment ratio (%) in Pre-primary schools in 1990 to that in 1996?
Give a very brief answer. 0.79. What is the ratio of the Gross enrolment ratio (%) in Primary schools in 1990 to that in 1996?
Offer a very short reply. 0.99. What is the ratio of the Gross enrolment ratio (%) of Secondary schools in 1990 to that in 1996?
Provide a short and direct response. 0.94. What is the ratio of the Gross enrolment ratio (%) in Tertiary schools in 1990 to that in 1996?
Your answer should be compact. 0.73. What is the ratio of the Gross enrolment ratio (%) of Pre-primary schools in 1991 to that in 1992?
Your answer should be compact. 0.95. What is the ratio of the Gross enrolment ratio (%) of Primary schools in 1991 to that in 1992?
Keep it short and to the point. 1. What is the ratio of the Gross enrolment ratio (%) of Secondary schools in 1991 to that in 1992?
Give a very brief answer. 0.96. What is the ratio of the Gross enrolment ratio (%) of Tertiary schools in 1991 to that in 1992?
Ensure brevity in your answer.  0.97. What is the ratio of the Gross enrolment ratio (%) of Pre-primary schools in 1991 to that in 1993?
Ensure brevity in your answer.  0.94. What is the ratio of the Gross enrolment ratio (%) of Primary schools in 1991 to that in 1993?
Offer a very short reply. 0.97. What is the ratio of the Gross enrolment ratio (%) of Secondary schools in 1991 to that in 1993?
Provide a succinct answer. 0.95. What is the ratio of the Gross enrolment ratio (%) of Tertiary schools in 1991 to that in 1993?
Your response must be concise. 0.95. What is the ratio of the Gross enrolment ratio (%) of Pre-primary schools in 1991 to that in 1994?
Ensure brevity in your answer.  0.95. What is the ratio of the Gross enrolment ratio (%) in Primary schools in 1991 to that in 1994?
Your response must be concise. 0.97. What is the ratio of the Gross enrolment ratio (%) in Secondary schools in 1991 to that in 1994?
Offer a very short reply. 0.95. What is the ratio of the Gross enrolment ratio (%) of Tertiary schools in 1991 to that in 1994?
Your answer should be compact. 0.92. What is the ratio of the Gross enrolment ratio (%) in Pre-primary schools in 1991 to that in 1995?
Ensure brevity in your answer.  0.9. What is the ratio of the Gross enrolment ratio (%) in Primary schools in 1991 to that in 1995?
Make the answer very short. 0.96. What is the ratio of the Gross enrolment ratio (%) of Secondary schools in 1991 to that in 1995?
Keep it short and to the point. 0.95. What is the ratio of the Gross enrolment ratio (%) of Tertiary schools in 1991 to that in 1995?
Provide a short and direct response. 0.89. What is the ratio of the Gross enrolment ratio (%) in Pre-primary schools in 1991 to that in 1996?
Offer a terse response. 0.83. What is the ratio of the Gross enrolment ratio (%) of Primary schools in 1991 to that in 1996?
Your answer should be very brief. 1. What is the ratio of the Gross enrolment ratio (%) in Secondary schools in 1991 to that in 1996?
Provide a short and direct response. 0.95. What is the ratio of the Gross enrolment ratio (%) of Tertiary schools in 1991 to that in 1996?
Make the answer very short. 0.87. What is the ratio of the Gross enrolment ratio (%) in Primary schools in 1992 to that in 1993?
Your answer should be compact. 0.98. What is the ratio of the Gross enrolment ratio (%) in Secondary schools in 1992 to that in 1993?
Your answer should be very brief. 1. What is the ratio of the Gross enrolment ratio (%) in Tertiary schools in 1992 to that in 1993?
Give a very brief answer. 0.97. What is the ratio of the Gross enrolment ratio (%) of Primary schools in 1992 to that in 1994?
Provide a short and direct response. 0.97. What is the ratio of the Gross enrolment ratio (%) of Secondary schools in 1992 to that in 1994?
Ensure brevity in your answer.  0.99. What is the ratio of the Gross enrolment ratio (%) of Tertiary schools in 1992 to that in 1994?
Ensure brevity in your answer.  0.94. What is the ratio of the Gross enrolment ratio (%) of Pre-primary schools in 1992 to that in 1995?
Give a very brief answer. 0.95. What is the ratio of the Gross enrolment ratio (%) in Primary schools in 1992 to that in 1995?
Your response must be concise. 0.97. What is the ratio of the Gross enrolment ratio (%) of Secondary schools in 1992 to that in 1995?
Keep it short and to the point. 0.99. What is the ratio of the Gross enrolment ratio (%) in Tertiary schools in 1992 to that in 1995?
Offer a terse response. 0.92. What is the ratio of the Gross enrolment ratio (%) of Pre-primary schools in 1992 to that in 1996?
Make the answer very short. 0.88. What is the ratio of the Gross enrolment ratio (%) in Primary schools in 1992 to that in 1996?
Your answer should be compact. 1. What is the ratio of the Gross enrolment ratio (%) of Secondary schools in 1992 to that in 1996?
Ensure brevity in your answer.  0.99. What is the ratio of the Gross enrolment ratio (%) in Tertiary schools in 1992 to that in 1996?
Provide a succinct answer. 0.89. What is the ratio of the Gross enrolment ratio (%) in Pre-primary schools in 1993 to that in 1994?
Keep it short and to the point. 1.01. What is the ratio of the Gross enrolment ratio (%) in Primary schools in 1993 to that in 1994?
Your answer should be compact. 0.99. What is the ratio of the Gross enrolment ratio (%) in Secondary schools in 1993 to that in 1994?
Make the answer very short. 1. What is the ratio of the Gross enrolment ratio (%) of Tertiary schools in 1993 to that in 1994?
Your answer should be compact. 0.97. What is the ratio of the Gross enrolment ratio (%) in Pre-primary schools in 1993 to that in 1995?
Your response must be concise. 0.96. What is the ratio of the Gross enrolment ratio (%) of Primary schools in 1993 to that in 1995?
Give a very brief answer. 0.99. What is the ratio of the Gross enrolment ratio (%) in Secondary schools in 1993 to that in 1995?
Provide a succinct answer. 1. What is the ratio of the Gross enrolment ratio (%) of Tertiary schools in 1993 to that in 1995?
Offer a terse response. 0.94. What is the ratio of the Gross enrolment ratio (%) of Pre-primary schools in 1993 to that in 1996?
Your answer should be compact. 0.88. What is the ratio of the Gross enrolment ratio (%) in Primary schools in 1993 to that in 1996?
Offer a terse response. 1.03. What is the ratio of the Gross enrolment ratio (%) of Secondary schools in 1993 to that in 1996?
Provide a short and direct response. 1. What is the ratio of the Gross enrolment ratio (%) in Tertiary schools in 1993 to that in 1996?
Ensure brevity in your answer.  0.92. What is the ratio of the Gross enrolment ratio (%) of Pre-primary schools in 1994 to that in 1995?
Offer a terse response. 0.95. What is the ratio of the Gross enrolment ratio (%) of Tertiary schools in 1994 to that in 1995?
Provide a short and direct response. 0.97. What is the ratio of the Gross enrolment ratio (%) of Pre-primary schools in 1994 to that in 1996?
Offer a very short reply. 0.88. What is the ratio of the Gross enrolment ratio (%) in Primary schools in 1994 to that in 1996?
Provide a succinct answer. 1.03. What is the ratio of the Gross enrolment ratio (%) of Secondary schools in 1994 to that in 1996?
Your response must be concise. 1. What is the ratio of the Gross enrolment ratio (%) in Tertiary schools in 1994 to that in 1996?
Your answer should be compact. 0.94. What is the ratio of the Gross enrolment ratio (%) of Pre-primary schools in 1995 to that in 1996?
Your answer should be very brief. 0.93. What is the ratio of the Gross enrolment ratio (%) in Primary schools in 1995 to that in 1996?
Your answer should be very brief. 1.04. What is the ratio of the Gross enrolment ratio (%) in Tertiary schools in 1995 to that in 1996?
Offer a terse response. 0.97. What is the difference between the highest and the second highest Gross enrolment ratio (%) of Pre-primary schools?
Offer a terse response. 2.32. What is the difference between the highest and the second highest Gross enrolment ratio (%) in Primary schools?
Your response must be concise. 0.85. What is the difference between the highest and the second highest Gross enrolment ratio (%) in Secondary schools?
Give a very brief answer. 0.11. What is the difference between the highest and the second highest Gross enrolment ratio (%) of Tertiary schools?
Your answer should be compact. 0.23. What is the difference between the highest and the lowest Gross enrolment ratio (%) of Pre-primary schools?
Make the answer very short. 6.6. What is the difference between the highest and the lowest Gross enrolment ratio (%) of Primary schools?
Provide a short and direct response. 4.88. What is the difference between the highest and the lowest Gross enrolment ratio (%) in Secondary schools?
Your answer should be very brief. 4.22. What is the difference between the highest and the lowest Gross enrolment ratio (%) of Tertiary schools?
Your response must be concise. 2.22. 